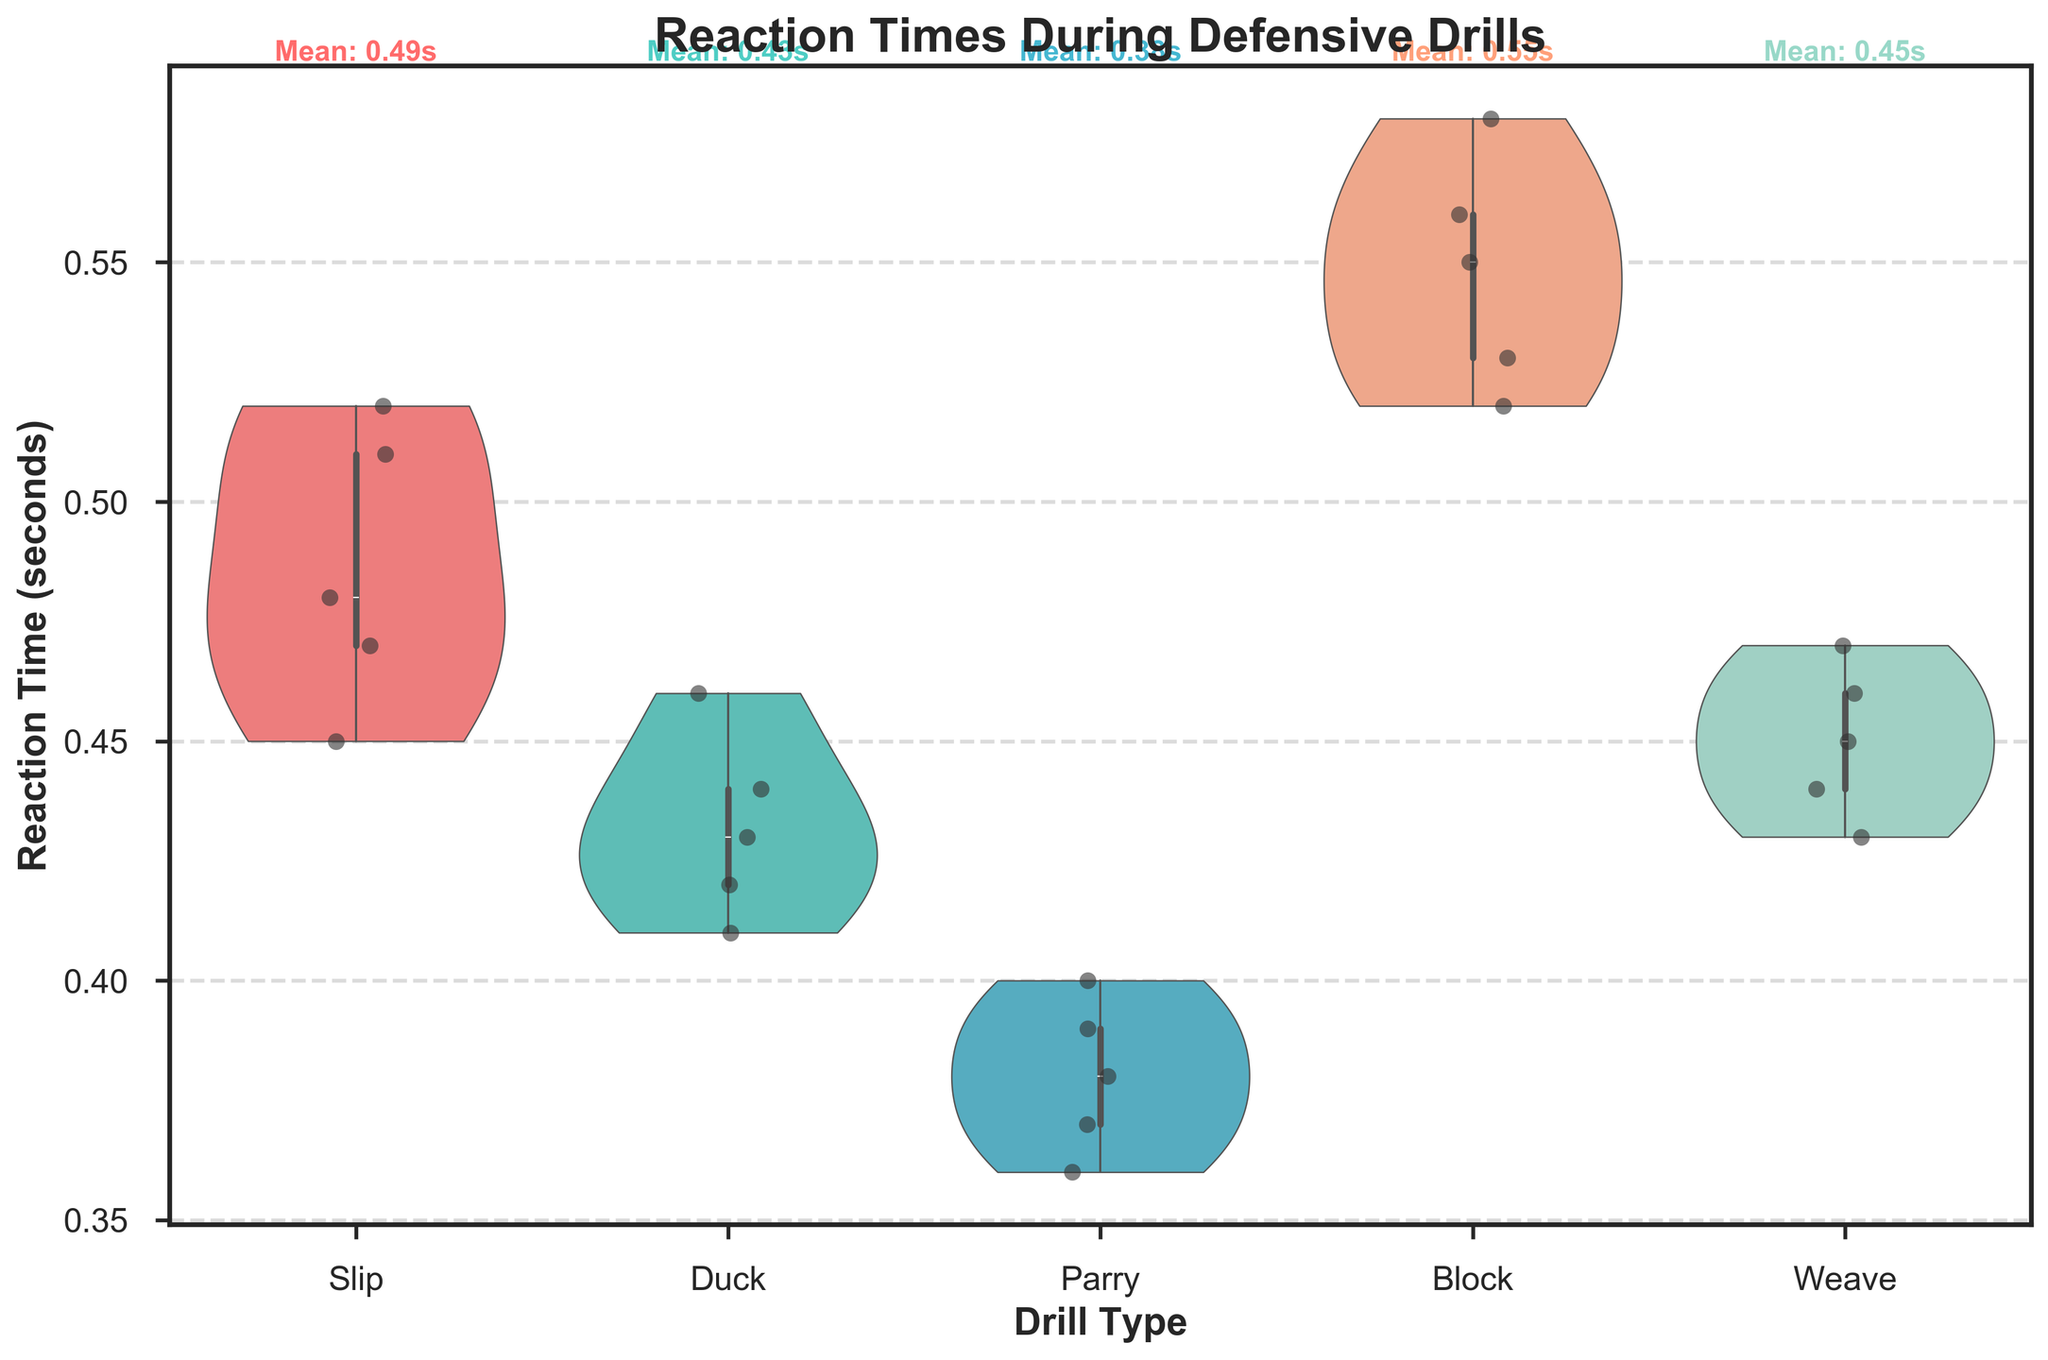What is the title of the figure? The title of the figure is usually displayed at the top of the chart. Here, it reads "Reaction Times During Defensive Drills."
Answer: Reaction Times During Defensive Drills What is the y-axis label on the figure? The y-axis label describes what is being measured or displayed along the vertical axis of the chart. In this case, the y-axis is labeled "Reaction Time (seconds)."
Answer: Reaction Time (seconds) Which drill type shows the widest range of reaction times? By examining the width of the violin plots, we can see which drill type has the widest range. The "Block" drill has the widest range because the violin plot is the most spread out on the y-axis.
Answer: Block Which drill type has the shortest average reaction time? The mean reaction time for each drill type is annotated at the top of each violin plot. The "Parry" drill shows the shortest average reaction time at 0.38 seconds.
Answer: Parry How many different drill types are represented in the figure? The violin plots and the x-axis of the chart display the different drill types. Counting these, we find there are five drill types: Slip, Duck, Parry, Block, and Weave.
Answer: 5 Which drill type has the most jittered points clustered around the mean? By looking at the concentration of jittered points near the center of the violin plots, the "Duck" drill has most points clustered close to the mean reaction time.
Answer: Duck What is the reaction time range for the "Slip" drill? The "Slip" drill violin plot shows that reaction times span from approximately 0.45 to 0.52 seconds.
Answer: 0.45 to 0.52 How does the average reaction time for "Weave" compare to that for "Slip"? The mean reaction time for "Weave" and "Slip" can be seen from the annotations. "Weave" has a mean of 0.45 seconds, while "Slip" has a mean of 0.49 seconds. Since 0.45 is less than 0.49, Weave has a faster reaction time.
Answer: Weave is faster Which drill type has the most variation in reaction times? The variation in reaction times can be deduced from the spread and shape of the violin plots. The "Block" drill type shows the most variation as it has the widest and most varied distribution.
Answer: Block Are there any drill types where no reaction times overlap with another drill type? By inspecting the range of each violin plot, we note that the ranges for each drill type overlap with at least one other drill type. Therefore, no drill type has completely non-overlapping reaction times.
Answer: No 